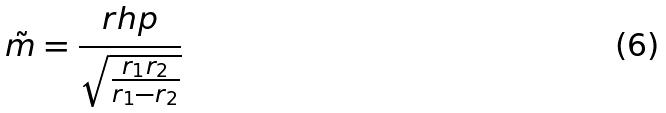<formula> <loc_0><loc_0><loc_500><loc_500>\tilde { m } = \frac { r h p } { \sqrt { \frac { r _ { 1 } r _ { 2 } } { r _ { 1 } - r _ { 2 } } } }</formula> 